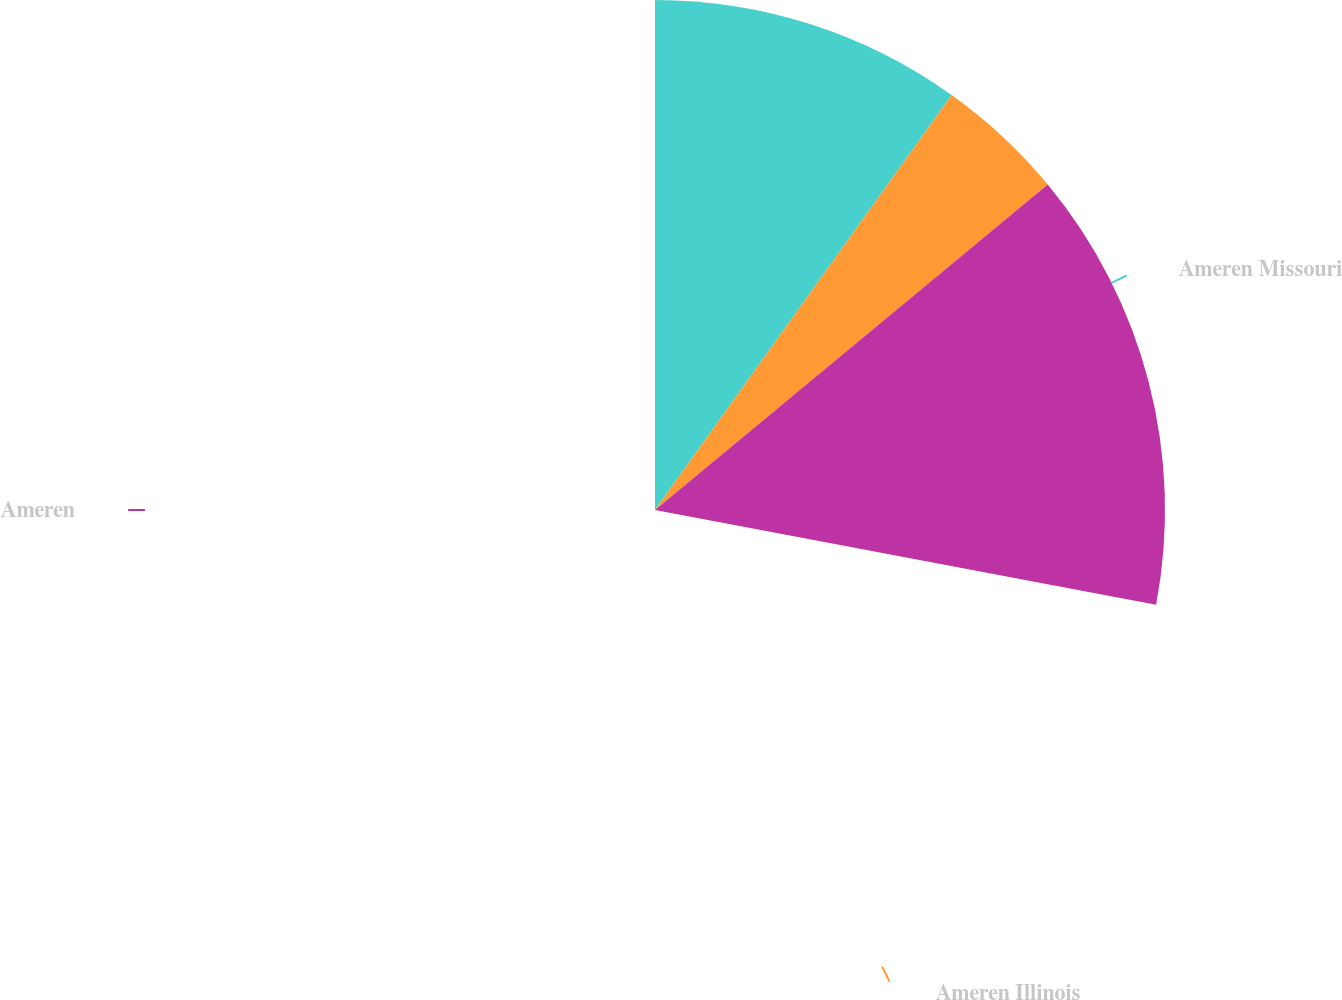Convert chart to OTSL. <chart><loc_0><loc_0><loc_500><loc_500><pie_chart><fcel>Ameren Missouri<fcel>Ameren Illinois<fcel>Ameren<nl><fcel>35.31%<fcel>14.69%<fcel>50.0%<nl></chart> 